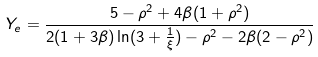<formula> <loc_0><loc_0><loc_500><loc_500>Y _ { e } = \frac { 5 - \rho ^ { 2 } + 4 \beta ( 1 + \rho ^ { 2 } ) } { 2 ( 1 + 3 \beta ) \ln ( 3 + \frac { 1 } { \xi } ) - \rho ^ { 2 } - 2 \beta ( 2 - \rho ^ { 2 } ) }</formula> 